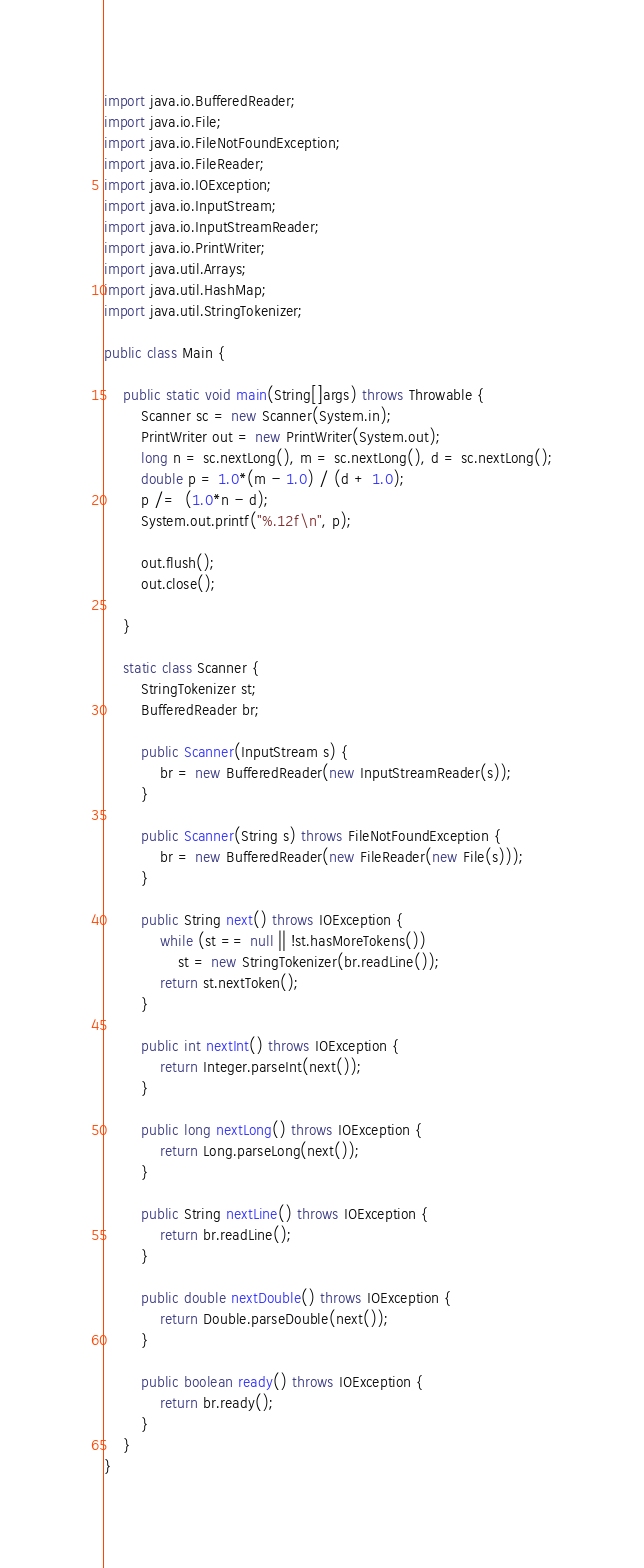<code> <loc_0><loc_0><loc_500><loc_500><_Java_>import java.io.BufferedReader;
import java.io.File;
import java.io.FileNotFoundException;
import java.io.FileReader;
import java.io.IOException;
import java.io.InputStream;
import java.io.InputStreamReader;
import java.io.PrintWriter;
import java.util.Arrays;
import java.util.HashMap;
import java.util.StringTokenizer;

public class Main {
	
	public static void main(String[]args) throws Throwable {
		Scanner sc = new Scanner(System.in);
		PrintWriter out = new PrintWriter(System.out);
		long n = sc.nextLong(), m = sc.nextLong(), d = sc.nextLong();
		double p = 1.0*(m - 1.0) / (d + 1.0);
		p /=  (1.0*n - d);
		System.out.printf("%.12f\n", p);
		
		out.flush();
		out.close();

	}

	static class Scanner {
		StringTokenizer st;
		BufferedReader br;

		public Scanner(InputStream s) {
			br = new BufferedReader(new InputStreamReader(s));
		}

		public Scanner(String s) throws FileNotFoundException {
			br = new BufferedReader(new FileReader(new File(s)));
		}

		public String next() throws IOException {
			while (st == null || !st.hasMoreTokens())
				st = new StringTokenizer(br.readLine());
			return st.nextToken();
		}

		public int nextInt() throws IOException {
			return Integer.parseInt(next());
		}

		public long nextLong() throws IOException {
			return Long.parseLong(next());
		}

		public String nextLine() throws IOException {
			return br.readLine();
		}

		public double nextDouble() throws IOException {
			return Double.parseDouble(next());
		}

		public boolean ready() throws IOException {
			return br.ready();
		}
	}
}
</code> 